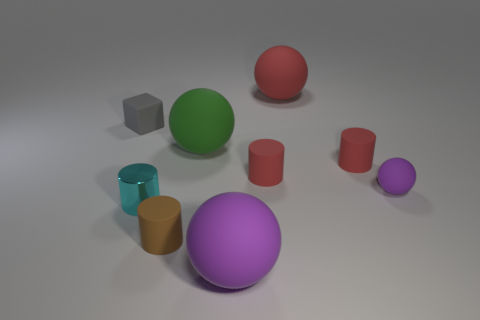Add 1 big objects. How many objects exist? 10 Subtract all blocks. How many objects are left? 8 Subtract all green balls. Subtract all gray rubber cubes. How many objects are left? 7 Add 6 red rubber things. How many red rubber things are left? 9 Add 7 purple spheres. How many purple spheres exist? 9 Subtract 0 purple cubes. How many objects are left? 9 